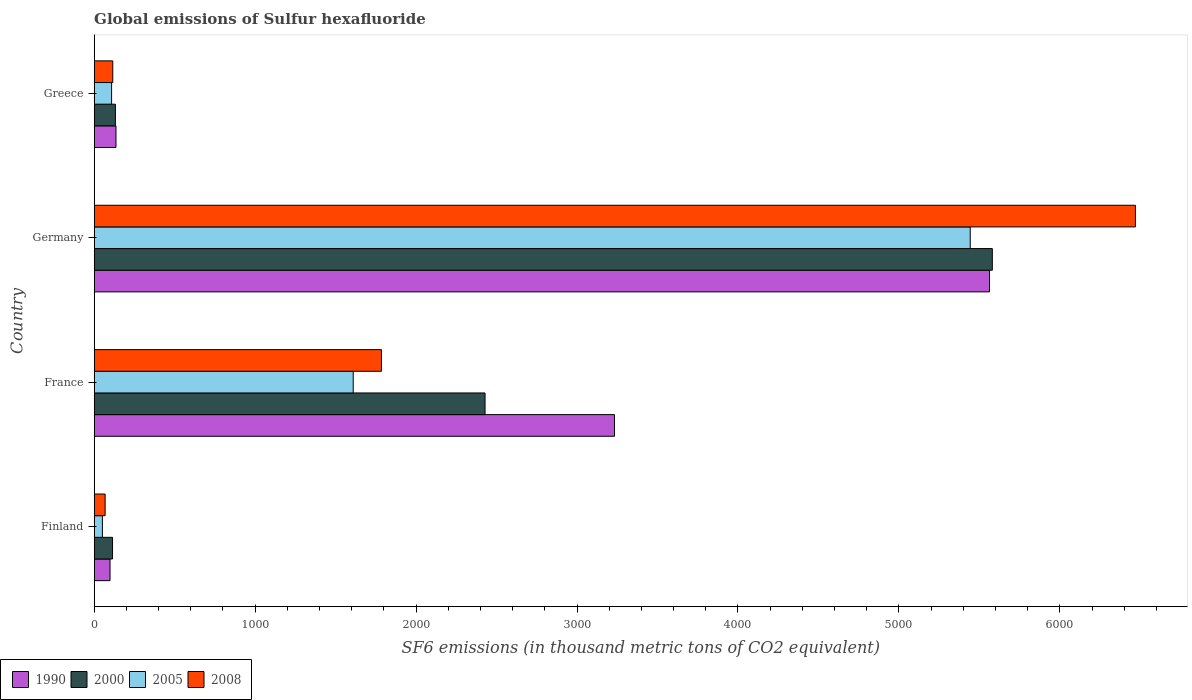How many groups of bars are there?
Give a very brief answer. 4. Are the number of bars on each tick of the Y-axis equal?
Make the answer very short. Yes. How many bars are there on the 2nd tick from the top?
Make the answer very short. 4. How many bars are there on the 2nd tick from the bottom?
Your answer should be very brief. 4. What is the global emissions of Sulfur hexafluoride in 2008 in Greece?
Offer a terse response. 115.4. Across all countries, what is the maximum global emissions of Sulfur hexafluoride in 2008?
Make the answer very short. 6469.6. Across all countries, what is the minimum global emissions of Sulfur hexafluoride in 2000?
Provide a short and direct response. 113.9. In which country was the global emissions of Sulfur hexafluoride in 2000 maximum?
Make the answer very short. Germany. In which country was the global emissions of Sulfur hexafluoride in 2000 minimum?
Your answer should be very brief. Finland. What is the total global emissions of Sulfur hexafluoride in 1990 in the graph?
Ensure brevity in your answer.  9029.5. What is the difference between the global emissions of Sulfur hexafluoride in 2000 in Finland and that in Germany?
Your answer should be very brief. -5466.5. What is the difference between the global emissions of Sulfur hexafluoride in 2008 in France and the global emissions of Sulfur hexafluoride in 1990 in Finland?
Provide a short and direct response. 1686.3. What is the average global emissions of Sulfur hexafluoride in 2000 per country?
Your answer should be compact. 2063.65. What is the difference between the global emissions of Sulfur hexafluoride in 1990 and global emissions of Sulfur hexafluoride in 2005 in Germany?
Ensure brevity in your answer.  119.7. What is the ratio of the global emissions of Sulfur hexafluoride in 2000 in France to that in Germany?
Offer a terse response. 0.44. Is the global emissions of Sulfur hexafluoride in 2000 in France less than that in Germany?
Offer a terse response. Yes. Is the difference between the global emissions of Sulfur hexafluoride in 1990 in Germany and Greece greater than the difference between the global emissions of Sulfur hexafluoride in 2005 in Germany and Greece?
Your answer should be compact. Yes. What is the difference between the highest and the second highest global emissions of Sulfur hexafluoride in 2005?
Your answer should be very brief. 3833.8. What is the difference between the highest and the lowest global emissions of Sulfur hexafluoride in 1990?
Offer a very short reply. 5464.5. In how many countries, is the global emissions of Sulfur hexafluoride in 2000 greater than the average global emissions of Sulfur hexafluoride in 2000 taken over all countries?
Ensure brevity in your answer.  2. Is it the case that in every country, the sum of the global emissions of Sulfur hexafluoride in 1990 and global emissions of Sulfur hexafluoride in 2000 is greater than the sum of global emissions of Sulfur hexafluoride in 2005 and global emissions of Sulfur hexafluoride in 2008?
Keep it short and to the point. No. What does the 2nd bar from the top in Finland represents?
Ensure brevity in your answer.  2005. Is it the case that in every country, the sum of the global emissions of Sulfur hexafluoride in 2008 and global emissions of Sulfur hexafluoride in 1990 is greater than the global emissions of Sulfur hexafluoride in 2000?
Provide a succinct answer. Yes. Are all the bars in the graph horizontal?
Your answer should be compact. Yes. How many countries are there in the graph?
Offer a terse response. 4. What is the difference between two consecutive major ticks on the X-axis?
Offer a terse response. 1000. Are the values on the major ticks of X-axis written in scientific E-notation?
Make the answer very short. No. Where does the legend appear in the graph?
Give a very brief answer. Bottom left. How many legend labels are there?
Keep it short and to the point. 4. What is the title of the graph?
Ensure brevity in your answer.  Global emissions of Sulfur hexafluoride. Does "1997" appear as one of the legend labels in the graph?
Your answer should be very brief. No. What is the label or title of the X-axis?
Offer a very short reply. SF6 emissions (in thousand metric tons of CO2 equivalent). What is the SF6 emissions (in thousand metric tons of CO2 equivalent) of 1990 in Finland?
Give a very brief answer. 98.4. What is the SF6 emissions (in thousand metric tons of CO2 equivalent) in 2000 in Finland?
Your response must be concise. 113.9. What is the SF6 emissions (in thousand metric tons of CO2 equivalent) in 2005 in Finland?
Give a very brief answer. 50.9. What is the SF6 emissions (in thousand metric tons of CO2 equivalent) of 2008 in Finland?
Ensure brevity in your answer.  67.9. What is the SF6 emissions (in thousand metric tons of CO2 equivalent) of 1990 in France?
Ensure brevity in your answer.  3232.8. What is the SF6 emissions (in thousand metric tons of CO2 equivalent) of 2000 in France?
Provide a succinct answer. 2428.5. What is the SF6 emissions (in thousand metric tons of CO2 equivalent) in 2005 in France?
Ensure brevity in your answer.  1609.4. What is the SF6 emissions (in thousand metric tons of CO2 equivalent) in 2008 in France?
Keep it short and to the point. 1784.7. What is the SF6 emissions (in thousand metric tons of CO2 equivalent) of 1990 in Germany?
Offer a terse response. 5562.9. What is the SF6 emissions (in thousand metric tons of CO2 equivalent) of 2000 in Germany?
Make the answer very short. 5580.4. What is the SF6 emissions (in thousand metric tons of CO2 equivalent) of 2005 in Germany?
Your response must be concise. 5443.2. What is the SF6 emissions (in thousand metric tons of CO2 equivalent) in 2008 in Germany?
Provide a succinct answer. 6469.6. What is the SF6 emissions (in thousand metric tons of CO2 equivalent) of 1990 in Greece?
Ensure brevity in your answer.  135.4. What is the SF6 emissions (in thousand metric tons of CO2 equivalent) in 2000 in Greece?
Your answer should be compact. 131.8. What is the SF6 emissions (in thousand metric tons of CO2 equivalent) in 2005 in Greece?
Ensure brevity in your answer.  108.1. What is the SF6 emissions (in thousand metric tons of CO2 equivalent) in 2008 in Greece?
Give a very brief answer. 115.4. Across all countries, what is the maximum SF6 emissions (in thousand metric tons of CO2 equivalent) of 1990?
Ensure brevity in your answer.  5562.9. Across all countries, what is the maximum SF6 emissions (in thousand metric tons of CO2 equivalent) of 2000?
Make the answer very short. 5580.4. Across all countries, what is the maximum SF6 emissions (in thousand metric tons of CO2 equivalent) of 2005?
Make the answer very short. 5443.2. Across all countries, what is the maximum SF6 emissions (in thousand metric tons of CO2 equivalent) in 2008?
Ensure brevity in your answer.  6469.6. Across all countries, what is the minimum SF6 emissions (in thousand metric tons of CO2 equivalent) of 1990?
Give a very brief answer. 98.4. Across all countries, what is the minimum SF6 emissions (in thousand metric tons of CO2 equivalent) of 2000?
Your answer should be compact. 113.9. Across all countries, what is the minimum SF6 emissions (in thousand metric tons of CO2 equivalent) in 2005?
Provide a succinct answer. 50.9. Across all countries, what is the minimum SF6 emissions (in thousand metric tons of CO2 equivalent) of 2008?
Give a very brief answer. 67.9. What is the total SF6 emissions (in thousand metric tons of CO2 equivalent) in 1990 in the graph?
Your answer should be compact. 9029.5. What is the total SF6 emissions (in thousand metric tons of CO2 equivalent) of 2000 in the graph?
Your response must be concise. 8254.6. What is the total SF6 emissions (in thousand metric tons of CO2 equivalent) of 2005 in the graph?
Ensure brevity in your answer.  7211.6. What is the total SF6 emissions (in thousand metric tons of CO2 equivalent) of 2008 in the graph?
Make the answer very short. 8437.6. What is the difference between the SF6 emissions (in thousand metric tons of CO2 equivalent) of 1990 in Finland and that in France?
Your answer should be compact. -3134.4. What is the difference between the SF6 emissions (in thousand metric tons of CO2 equivalent) in 2000 in Finland and that in France?
Make the answer very short. -2314.6. What is the difference between the SF6 emissions (in thousand metric tons of CO2 equivalent) in 2005 in Finland and that in France?
Provide a succinct answer. -1558.5. What is the difference between the SF6 emissions (in thousand metric tons of CO2 equivalent) of 2008 in Finland and that in France?
Provide a short and direct response. -1716.8. What is the difference between the SF6 emissions (in thousand metric tons of CO2 equivalent) in 1990 in Finland and that in Germany?
Offer a very short reply. -5464.5. What is the difference between the SF6 emissions (in thousand metric tons of CO2 equivalent) of 2000 in Finland and that in Germany?
Ensure brevity in your answer.  -5466.5. What is the difference between the SF6 emissions (in thousand metric tons of CO2 equivalent) of 2005 in Finland and that in Germany?
Give a very brief answer. -5392.3. What is the difference between the SF6 emissions (in thousand metric tons of CO2 equivalent) in 2008 in Finland and that in Germany?
Make the answer very short. -6401.7. What is the difference between the SF6 emissions (in thousand metric tons of CO2 equivalent) in 1990 in Finland and that in Greece?
Offer a terse response. -37. What is the difference between the SF6 emissions (in thousand metric tons of CO2 equivalent) in 2000 in Finland and that in Greece?
Offer a very short reply. -17.9. What is the difference between the SF6 emissions (in thousand metric tons of CO2 equivalent) in 2005 in Finland and that in Greece?
Your answer should be very brief. -57.2. What is the difference between the SF6 emissions (in thousand metric tons of CO2 equivalent) in 2008 in Finland and that in Greece?
Offer a very short reply. -47.5. What is the difference between the SF6 emissions (in thousand metric tons of CO2 equivalent) of 1990 in France and that in Germany?
Offer a very short reply. -2330.1. What is the difference between the SF6 emissions (in thousand metric tons of CO2 equivalent) in 2000 in France and that in Germany?
Give a very brief answer. -3151.9. What is the difference between the SF6 emissions (in thousand metric tons of CO2 equivalent) in 2005 in France and that in Germany?
Give a very brief answer. -3833.8. What is the difference between the SF6 emissions (in thousand metric tons of CO2 equivalent) of 2008 in France and that in Germany?
Offer a very short reply. -4684.9. What is the difference between the SF6 emissions (in thousand metric tons of CO2 equivalent) in 1990 in France and that in Greece?
Make the answer very short. 3097.4. What is the difference between the SF6 emissions (in thousand metric tons of CO2 equivalent) of 2000 in France and that in Greece?
Offer a very short reply. 2296.7. What is the difference between the SF6 emissions (in thousand metric tons of CO2 equivalent) in 2005 in France and that in Greece?
Offer a terse response. 1501.3. What is the difference between the SF6 emissions (in thousand metric tons of CO2 equivalent) of 2008 in France and that in Greece?
Make the answer very short. 1669.3. What is the difference between the SF6 emissions (in thousand metric tons of CO2 equivalent) in 1990 in Germany and that in Greece?
Your answer should be very brief. 5427.5. What is the difference between the SF6 emissions (in thousand metric tons of CO2 equivalent) of 2000 in Germany and that in Greece?
Your answer should be very brief. 5448.6. What is the difference between the SF6 emissions (in thousand metric tons of CO2 equivalent) in 2005 in Germany and that in Greece?
Provide a succinct answer. 5335.1. What is the difference between the SF6 emissions (in thousand metric tons of CO2 equivalent) of 2008 in Germany and that in Greece?
Give a very brief answer. 6354.2. What is the difference between the SF6 emissions (in thousand metric tons of CO2 equivalent) of 1990 in Finland and the SF6 emissions (in thousand metric tons of CO2 equivalent) of 2000 in France?
Your answer should be compact. -2330.1. What is the difference between the SF6 emissions (in thousand metric tons of CO2 equivalent) of 1990 in Finland and the SF6 emissions (in thousand metric tons of CO2 equivalent) of 2005 in France?
Offer a very short reply. -1511. What is the difference between the SF6 emissions (in thousand metric tons of CO2 equivalent) in 1990 in Finland and the SF6 emissions (in thousand metric tons of CO2 equivalent) in 2008 in France?
Your answer should be very brief. -1686.3. What is the difference between the SF6 emissions (in thousand metric tons of CO2 equivalent) of 2000 in Finland and the SF6 emissions (in thousand metric tons of CO2 equivalent) of 2005 in France?
Provide a succinct answer. -1495.5. What is the difference between the SF6 emissions (in thousand metric tons of CO2 equivalent) of 2000 in Finland and the SF6 emissions (in thousand metric tons of CO2 equivalent) of 2008 in France?
Provide a short and direct response. -1670.8. What is the difference between the SF6 emissions (in thousand metric tons of CO2 equivalent) in 2005 in Finland and the SF6 emissions (in thousand metric tons of CO2 equivalent) in 2008 in France?
Offer a terse response. -1733.8. What is the difference between the SF6 emissions (in thousand metric tons of CO2 equivalent) of 1990 in Finland and the SF6 emissions (in thousand metric tons of CO2 equivalent) of 2000 in Germany?
Offer a very short reply. -5482. What is the difference between the SF6 emissions (in thousand metric tons of CO2 equivalent) in 1990 in Finland and the SF6 emissions (in thousand metric tons of CO2 equivalent) in 2005 in Germany?
Your answer should be very brief. -5344.8. What is the difference between the SF6 emissions (in thousand metric tons of CO2 equivalent) of 1990 in Finland and the SF6 emissions (in thousand metric tons of CO2 equivalent) of 2008 in Germany?
Provide a short and direct response. -6371.2. What is the difference between the SF6 emissions (in thousand metric tons of CO2 equivalent) of 2000 in Finland and the SF6 emissions (in thousand metric tons of CO2 equivalent) of 2005 in Germany?
Your answer should be very brief. -5329.3. What is the difference between the SF6 emissions (in thousand metric tons of CO2 equivalent) in 2000 in Finland and the SF6 emissions (in thousand metric tons of CO2 equivalent) in 2008 in Germany?
Offer a very short reply. -6355.7. What is the difference between the SF6 emissions (in thousand metric tons of CO2 equivalent) in 2005 in Finland and the SF6 emissions (in thousand metric tons of CO2 equivalent) in 2008 in Germany?
Your answer should be very brief. -6418.7. What is the difference between the SF6 emissions (in thousand metric tons of CO2 equivalent) in 1990 in Finland and the SF6 emissions (in thousand metric tons of CO2 equivalent) in 2000 in Greece?
Offer a terse response. -33.4. What is the difference between the SF6 emissions (in thousand metric tons of CO2 equivalent) in 2005 in Finland and the SF6 emissions (in thousand metric tons of CO2 equivalent) in 2008 in Greece?
Provide a succinct answer. -64.5. What is the difference between the SF6 emissions (in thousand metric tons of CO2 equivalent) in 1990 in France and the SF6 emissions (in thousand metric tons of CO2 equivalent) in 2000 in Germany?
Provide a succinct answer. -2347.6. What is the difference between the SF6 emissions (in thousand metric tons of CO2 equivalent) of 1990 in France and the SF6 emissions (in thousand metric tons of CO2 equivalent) of 2005 in Germany?
Make the answer very short. -2210.4. What is the difference between the SF6 emissions (in thousand metric tons of CO2 equivalent) in 1990 in France and the SF6 emissions (in thousand metric tons of CO2 equivalent) in 2008 in Germany?
Give a very brief answer. -3236.8. What is the difference between the SF6 emissions (in thousand metric tons of CO2 equivalent) of 2000 in France and the SF6 emissions (in thousand metric tons of CO2 equivalent) of 2005 in Germany?
Your response must be concise. -3014.7. What is the difference between the SF6 emissions (in thousand metric tons of CO2 equivalent) in 2000 in France and the SF6 emissions (in thousand metric tons of CO2 equivalent) in 2008 in Germany?
Your answer should be very brief. -4041.1. What is the difference between the SF6 emissions (in thousand metric tons of CO2 equivalent) of 2005 in France and the SF6 emissions (in thousand metric tons of CO2 equivalent) of 2008 in Germany?
Offer a terse response. -4860.2. What is the difference between the SF6 emissions (in thousand metric tons of CO2 equivalent) in 1990 in France and the SF6 emissions (in thousand metric tons of CO2 equivalent) in 2000 in Greece?
Offer a terse response. 3101. What is the difference between the SF6 emissions (in thousand metric tons of CO2 equivalent) of 1990 in France and the SF6 emissions (in thousand metric tons of CO2 equivalent) of 2005 in Greece?
Offer a terse response. 3124.7. What is the difference between the SF6 emissions (in thousand metric tons of CO2 equivalent) in 1990 in France and the SF6 emissions (in thousand metric tons of CO2 equivalent) in 2008 in Greece?
Your response must be concise. 3117.4. What is the difference between the SF6 emissions (in thousand metric tons of CO2 equivalent) of 2000 in France and the SF6 emissions (in thousand metric tons of CO2 equivalent) of 2005 in Greece?
Ensure brevity in your answer.  2320.4. What is the difference between the SF6 emissions (in thousand metric tons of CO2 equivalent) of 2000 in France and the SF6 emissions (in thousand metric tons of CO2 equivalent) of 2008 in Greece?
Offer a very short reply. 2313.1. What is the difference between the SF6 emissions (in thousand metric tons of CO2 equivalent) in 2005 in France and the SF6 emissions (in thousand metric tons of CO2 equivalent) in 2008 in Greece?
Ensure brevity in your answer.  1494. What is the difference between the SF6 emissions (in thousand metric tons of CO2 equivalent) of 1990 in Germany and the SF6 emissions (in thousand metric tons of CO2 equivalent) of 2000 in Greece?
Make the answer very short. 5431.1. What is the difference between the SF6 emissions (in thousand metric tons of CO2 equivalent) in 1990 in Germany and the SF6 emissions (in thousand metric tons of CO2 equivalent) in 2005 in Greece?
Your answer should be compact. 5454.8. What is the difference between the SF6 emissions (in thousand metric tons of CO2 equivalent) in 1990 in Germany and the SF6 emissions (in thousand metric tons of CO2 equivalent) in 2008 in Greece?
Keep it short and to the point. 5447.5. What is the difference between the SF6 emissions (in thousand metric tons of CO2 equivalent) of 2000 in Germany and the SF6 emissions (in thousand metric tons of CO2 equivalent) of 2005 in Greece?
Make the answer very short. 5472.3. What is the difference between the SF6 emissions (in thousand metric tons of CO2 equivalent) in 2000 in Germany and the SF6 emissions (in thousand metric tons of CO2 equivalent) in 2008 in Greece?
Keep it short and to the point. 5465. What is the difference between the SF6 emissions (in thousand metric tons of CO2 equivalent) of 2005 in Germany and the SF6 emissions (in thousand metric tons of CO2 equivalent) of 2008 in Greece?
Make the answer very short. 5327.8. What is the average SF6 emissions (in thousand metric tons of CO2 equivalent) of 1990 per country?
Provide a succinct answer. 2257.38. What is the average SF6 emissions (in thousand metric tons of CO2 equivalent) in 2000 per country?
Ensure brevity in your answer.  2063.65. What is the average SF6 emissions (in thousand metric tons of CO2 equivalent) in 2005 per country?
Your answer should be very brief. 1802.9. What is the average SF6 emissions (in thousand metric tons of CO2 equivalent) of 2008 per country?
Offer a terse response. 2109.4. What is the difference between the SF6 emissions (in thousand metric tons of CO2 equivalent) in 1990 and SF6 emissions (in thousand metric tons of CO2 equivalent) in 2000 in Finland?
Keep it short and to the point. -15.5. What is the difference between the SF6 emissions (in thousand metric tons of CO2 equivalent) in 1990 and SF6 emissions (in thousand metric tons of CO2 equivalent) in 2005 in Finland?
Your response must be concise. 47.5. What is the difference between the SF6 emissions (in thousand metric tons of CO2 equivalent) in 1990 and SF6 emissions (in thousand metric tons of CO2 equivalent) in 2008 in Finland?
Make the answer very short. 30.5. What is the difference between the SF6 emissions (in thousand metric tons of CO2 equivalent) in 2000 and SF6 emissions (in thousand metric tons of CO2 equivalent) in 2005 in Finland?
Offer a very short reply. 63. What is the difference between the SF6 emissions (in thousand metric tons of CO2 equivalent) of 1990 and SF6 emissions (in thousand metric tons of CO2 equivalent) of 2000 in France?
Your answer should be very brief. 804.3. What is the difference between the SF6 emissions (in thousand metric tons of CO2 equivalent) in 1990 and SF6 emissions (in thousand metric tons of CO2 equivalent) in 2005 in France?
Offer a very short reply. 1623.4. What is the difference between the SF6 emissions (in thousand metric tons of CO2 equivalent) of 1990 and SF6 emissions (in thousand metric tons of CO2 equivalent) of 2008 in France?
Give a very brief answer. 1448.1. What is the difference between the SF6 emissions (in thousand metric tons of CO2 equivalent) of 2000 and SF6 emissions (in thousand metric tons of CO2 equivalent) of 2005 in France?
Offer a very short reply. 819.1. What is the difference between the SF6 emissions (in thousand metric tons of CO2 equivalent) in 2000 and SF6 emissions (in thousand metric tons of CO2 equivalent) in 2008 in France?
Provide a short and direct response. 643.8. What is the difference between the SF6 emissions (in thousand metric tons of CO2 equivalent) in 2005 and SF6 emissions (in thousand metric tons of CO2 equivalent) in 2008 in France?
Offer a very short reply. -175.3. What is the difference between the SF6 emissions (in thousand metric tons of CO2 equivalent) of 1990 and SF6 emissions (in thousand metric tons of CO2 equivalent) of 2000 in Germany?
Your answer should be very brief. -17.5. What is the difference between the SF6 emissions (in thousand metric tons of CO2 equivalent) in 1990 and SF6 emissions (in thousand metric tons of CO2 equivalent) in 2005 in Germany?
Make the answer very short. 119.7. What is the difference between the SF6 emissions (in thousand metric tons of CO2 equivalent) in 1990 and SF6 emissions (in thousand metric tons of CO2 equivalent) in 2008 in Germany?
Ensure brevity in your answer.  -906.7. What is the difference between the SF6 emissions (in thousand metric tons of CO2 equivalent) of 2000 and SF6 emissions (in thousand metric tons of CO2 equivalent) of 2005 in Germany?
Your answer should be compact. 137.2. What is the difference between the SF6 emissions (in thousand metric tons of CO2 equivalent) in 2000 and SF6 emissions (in thousand metric tons of CO2 equivalent) in 2008 in Germany?
Offer a very short reply. -889.2. What is the difference between the SF6 emissions (in thousand metric tons of CO2 equivalent) in 2005 and SF6 emissions (in thousand metric tons of CO2 equivalent) in 2008 in Germany?
Keep it short and to the point. -1026.4. What is the difference between the SF6 emissions (in thousand metric tons of CO2 equivalent) in 1990 and SF6 emissions (in thousand metric tons of CO2 equivalent) in 2000 in Greece?
Ensure brevity in your answer.  3.6. What is the difference between the SF6 emissions (in thousand metric tons of CO2 equivalent) of 1990 and SF6 emissions (in thousand metric tons of CO2 equivalent) of 2005 in Greece?
Offer a terse response. 27.3. What is the difference between the SF6 emissions (in thousand metric tons of CO2 equivalent) in 2000 and SF6 emissions (in thousand metric tons of CO2 equivalent) in 2005 in Greece?
Your answer should be compact. 23.7. What is the difference between the SF6 emissions (in thousand metric tons of CO2 equivalent) of 2000 and SF6 emissions (in thousand metric tons of CO2 equivalent) of 2008 in Greece?
Give a very brief answer. 16.4. What is the ratio of the SF6 emissions (in thousand metric tons of CO2 equivalent) in 1990 in Finland to that in France?
Give a very brief answer. 0.03. What is the ratio of the SF6 emissions (in thousand metric tons of CO2 equivalent) of 2000 in Finland to that in France?
Give a very brief answer. 0.05. What is the ratio of the SF6 emissions (in thousand metric tons of CO2 equivalent) in 2005 in Finland to that in France?
Make the answer very short. 0.03. What is the ratio of the SF6 emissions (in thousand metric tons of CO2 equivalent) of 2008 in Finland to that in France?
Ensure brevity in your answer.  0.04. What is the ratio of the SF6 emissions (in thousand metric tons of CO2 equivalent) in 1990 in Finland to that in Germany?
Make the answer very short. 0.02. What is the ratio of the SF6 emissions (in thousand metric tons of CO2 equivalent) in 2000 in Finland to that in Germany?
Your answer should be compact. 0.02. What is the ratio of the SF6 emissions (in thousand metric tons of CO2 equivalent) of 2005 in Finland to that in Germany?
Make the answer very short. 0.01. What is the ratio of the SF6 emissions (in thousand metric tons of CO2 equivalent) in 2008 in Finland to that in Germany?
Offer a terse response. 0.01. What is the ratio of the SF6 emissions (in thousand metric tons of CO2 equivalent) of 1990 in Finland to that in Greece?
Offer a terse response. 0.73. What is the ratio of the SF6 emissions (in thousand metric tons of CO2 equivalent) in 2000 in Finland to that in Greece?
Provide a succinct answer. 0.86. What is the ratio of the SF6 emissions (in thousand metric tons of CO2 equivalent) in 2005 in Finland to that in Greece?
Give a very brief answer. 0.47. What is the ratio of the SF6 emissions (in thousand metric tons of CO2 equivalent) of 2008 in Finland to that in Greece?
Your response must be concise. 0.59. What is the ratio of the SF6 emissions (in thousand metric tons of CO2 equivalent) of 1990 in France to that in Germany?
Provide a succinct answer. 0.58. What is the ratio of the SF6 emissions (in thousand metric tons of CO2 equivalent) in 2000 in France to that in Germany?
Offer a very short reply. 0.44. What is the ratio of the SF6 emissions (in thousand metric tons of CO2 equivalent) of 2005 in France to that in Germany?
Give a very brief answer. 0.3. What is the ratio of the SF6 emissions (in thousand metric tons of CO2 equivalent) of 2008 in France to that in Germany?
Provide a short and direct response. 0.28. What is the ratio of the SF6 emissions (in thousand metric tons of CO2 equivalent) of 1990 in France to that in Greece?
Your answer should be compact. 23.88. What is the ratio of the SF6 emissions (in thousand metric tons of CO2 equivalent) of 2000 in France to that in Greece?
Give a very brief answer. 18.43. What is the ratio of the SF6 emissions (in thousand metric tons of CO2 equivalent) of 2005 in France to that in Greece?
Provide a short and direct response. 14.89. What is the ratio of the SF6 emissions (in thousand metric tons of CO2 equivalent) in 2008 in France to that in Greece?
Offer a very short reply. 15.47. What is the ratio of the SF6 emissions (in thousand metric tons of CO2 equivalent) of 1990 in Germany to that in Greece?
Make the answer very short. 41.08. What is the ratio of the SF6 emissions (in thousand metric tons of CO2 equivalent) in 2000 in Germany to that in Greece?
Ensure brevity in your answer.  42.34. What is the ratio of the SF6 emissions (in thousand metric tons of CO2 equivalent) in 2005 in Germany to that in Greece?
Offer a terse response. 50.35. What is the ratio of the SF6 emissions (in thousand metric tons of CO2 equivalent) in 2008 in Germany to that in Greece?
Provide a succinct answer. 56.06. What is the difference between the highest and the second highest SF6 emissions (in thousand metric tons of CO2 equivalent) in 1990?
Provide a succinct answer. 2330.1. What is the difference between the highest and the second highest SF6 emissions (in thousand metric tons of CO2 equivalent) in 2000?
Provide a succinct answer. 3151.9. What is the difference between the highest and the second highest SF6 emissions (in thousand metric tons of CO2 equivalent) in 2005?
Ensure brevity in your answer.  3833.8. What is the difference between the highest and the second highest SF6 emissions (in thousand metric tons of CO2 equivalent) of 2008?
Make the answer very short. 4684.9. What is the difference between the highest and the lowest SF6 emissions (in thousand metric tons of CO2 equivalent) in 1990?
Offer a very short reply. 5464.5. What is the difference between the highest and the lowest SF6 emissions (in thousand metric tons of CO2 equivalent) of 2000?
Make the answer very short. 5466.5. What is the difference between the highest and the lowest SF6 emissions (in thousand metric tons of CO2 equivalent) of 2005?
Your answer should be compact. 5392.3. What is the difference between the highest and the lowest SF6 emissions (in thousand metric tons of CO2 equivalent) of 2008?
Keep it short and to the point. 6401.7. 